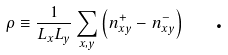<formula> <loc_0><loc_0><loc_500><loc_500>\rho \equiv \frac { 1 } { L _ { x } L _ { y } } \sum _ { x , y } \left ( n _ { x y } ^ { + } - n _ { x y } ^ { - } \right ) \quad \text {.}</formula> 